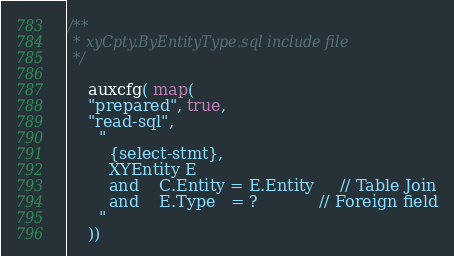Convert code to text. <code><loc_0><loc_0><loc_500><loc_500><_SQL_>/**
 * xyCpty.ByEntityType.sql include file
 */

    auxcfg( map(
    "prepared", true,
    "read-sql",
      "
        {select-stmt},
        XYEntity E
        and    C.Entity = E.Entity     // Table Join
        and    E.Type   = ?            // Foreign field
      "
    ))
</code> 